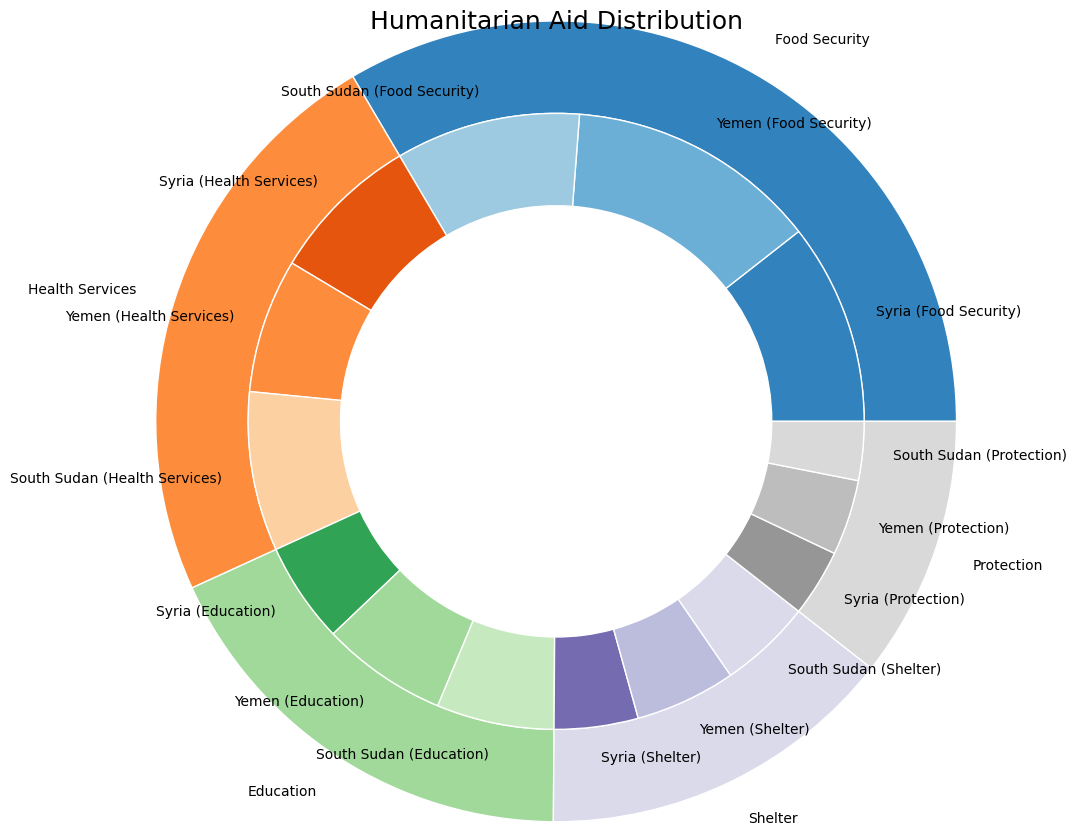What type of humanitarian aid receives the highest total value? First, identify the outer section of the pie that represents each type of aid. The segment with the largest size indicates the aid type with the highest total value. "Food Security" occupies the largest portion of the outer pie.
Answer: Food Security Which country receives the most aid for Health Services? Look at the inner pie slices within the outer segment labeled "Health Services." The slice with the largest portion within the "Health Services" segment represents the recipient country with the most aid for this type. Yemen has the largest slice.
Answer: South Sudan What is the combined value of aid received by Syria for Food Security and Health Services? Identify the slices within the outer segments labeled "Food Security" and "Health Services" that pertain to Syria. Sum the values of these slices: 1200 (Food Security) + 900 (Health Services).
Answer: 2100 Which type of aid has the smallest total value? Compare the sizes of the outer segments. The smallest segment represents the type of aid with the lowest total value. "Protection" has the smallest slice.
Answer: Protection How does the aid value for Shelter in South Sudan compare to that in Yemen? Identify the slices for "Shelter" aid received by South Sudan and Yemen. Compare their sizes; Yemen has a slice value of 600, while South Sudan's slice value is 550.
Answer: Less in South Sudan How much more aid does Yemen receive for Food Security compared to South Sudan? Identify the "Food Security" slices for Yemen and South Sudan. Subtract the value for South Sudan (1100) from the value for Yemen (1500): 1500 - 1100.
Answer: 400 Which aid type and recipient country combination represent the smallest slice in the inner pie? Find the smallest slice among the inner segments by comparing the sizes directly. The combination of "Protection" aid for South Sudan forms the smallest segment.
Answer: Protection for South Sudan What is the total value of aid received by Yemen across all types? Sum the values for Yemen's aid across each type: 1500 (Food Security) + 800 (Health Services) + 750 (Education) + 600 (Shelter) + 450 (Protection).
Answer: 4100 Is the portion of aid dedicated to Education in Syria larger or smaller than that for Health Services in Yemen? Compare the size of the "Education" slice for Syria to the "Health Services" slice for Yemen. The "Health Services" slice for Yemen is larger.
Answer: Smaller 